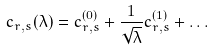Convert formula to latex. <formula><loc_0><loc_0><loc_500><loc_500>c _ { r , s } ( \lambda ) = c _ { r , s } ^ { ( 0 ) } + \frac { 1 } { \sqrt { \lambda } } c _ { r , s } ^ { ( 1 ) } + \dots</formula> 